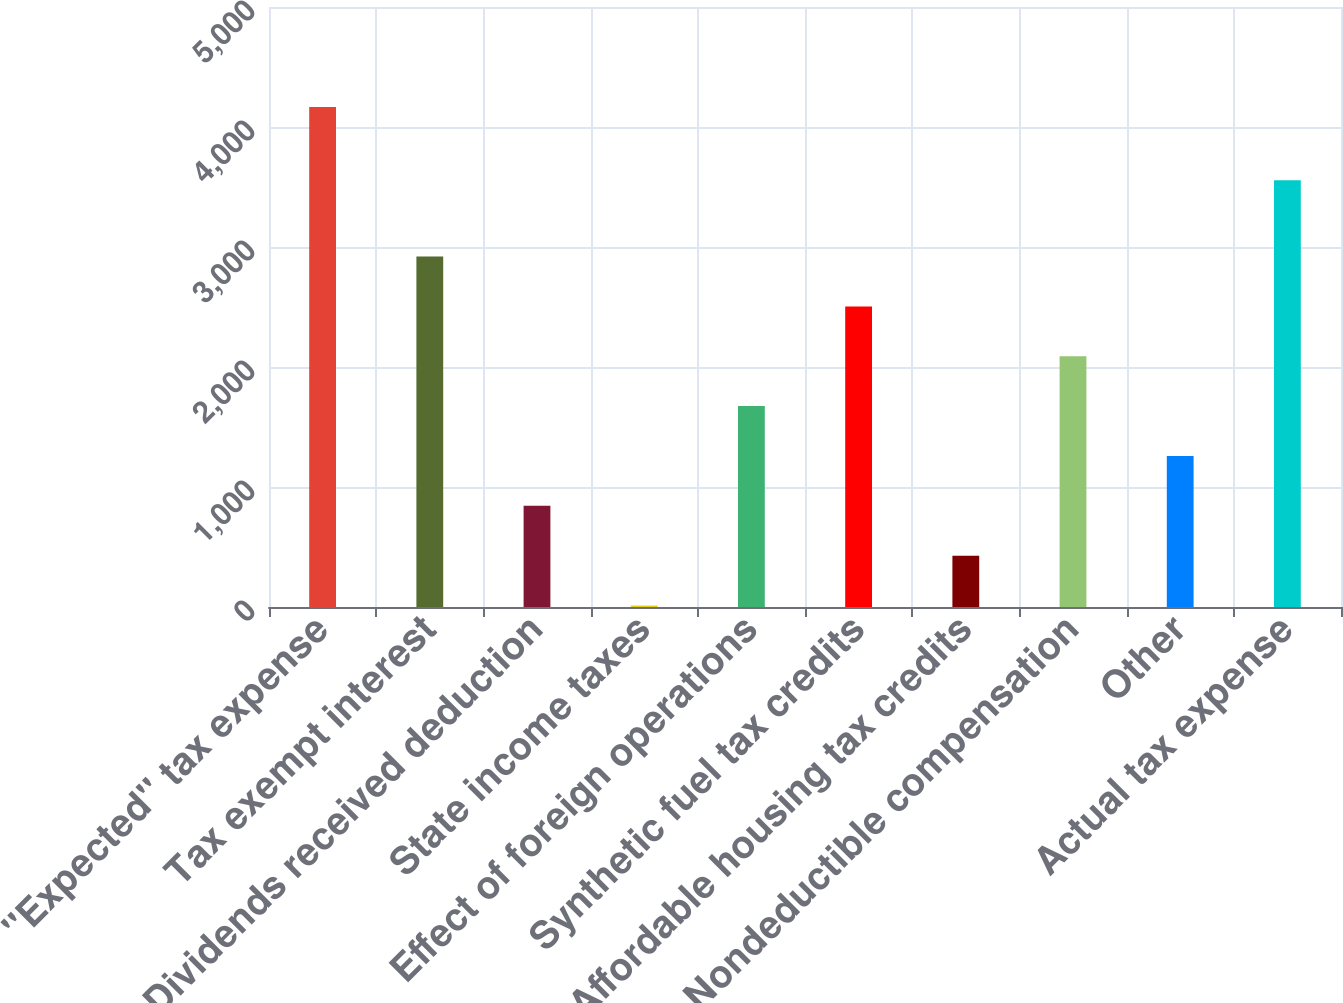Convert chart. <chart><loc_0><loc_0><loc_500><loc_500><bar_chart><fcel>''Expected'' tax expense<fcel>Tax exempt interest<fcel>Dividends received deduction<fcel>State income taxes<fcel>Effect of foreign operations<fcel>Synthetic fuel tax credits<fcel>Affordable housing tax credits<fcel>Nondeductible compensation<fcel>Other<fcel>Actual tax expense<nl><fcel>4167<fcel>2920.5<fcel>843<fcel>12<fcel>1674<fcel>2505<fcel>427.5<fcel>2089.5<fcel>1258.5<fcel>3556<nl></chart> 